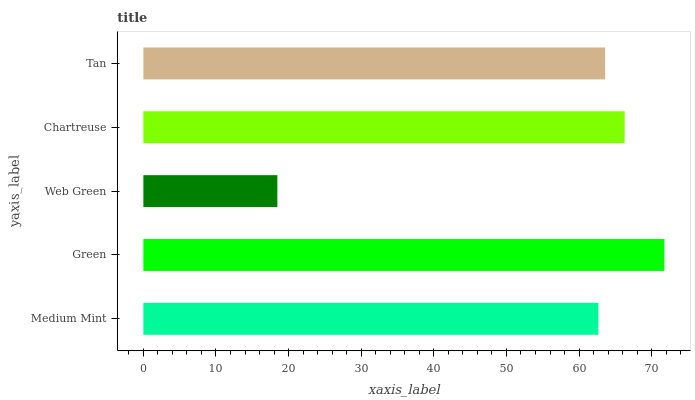Is Web Green the minimum?
Answer yes or no. Yes. Is Green the maximum?
Answer yes or no. Yes. Is Green the minimum?
Answer yes or no. No. Is Web Green the maximum?
Answer yes or no. No. Is Green greater than Web Green?
Answer yes or no. Yes. Is Web Green less than Green?
Answer yes or no. Yes. Is Web Green greater than Green?
Answer yes or no. No. Is Green less than Web Green?
Answer yes or no. No. Is Tan the high median?
Answer yes or no. Yes. Is Tan the low median?
Answer yes or no. Yes. Is Chartreuse the high median?
Answer yes or no. No. Is Medium Mint the low median?
Answer yes or no. No. 